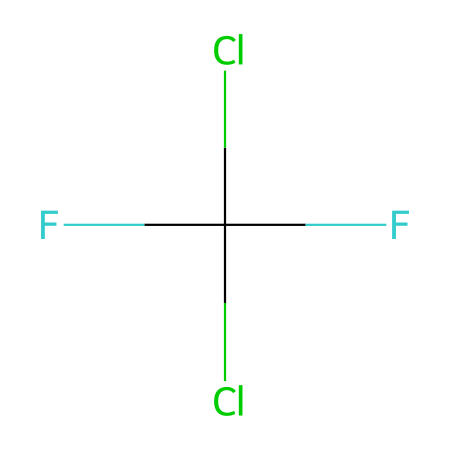What is the molecular formula of Freon-12? The SMILES representation shows the atoms present: carbon (C), fluorine (F), and chlorine (Cl). There's one carbon atom, two chlorine atoms, and four fluorine atoms. The molecular formula can be constructed as CCl2F2.
Answer: CCl2F2 How many halogen atoms are present in Freon-12? The SMILES structure indicates two chlorine (Cl) and four fluorine (F) atoms, making it a total of six halogen atoms present.
Answer: six What is the degree of saturation in Freon-12? Degree of saturation refers to the number of double or triple bonds present; as Freon-12 has single bonds only, it is fully saturated with hydrogen, yet has two halogen atoms making it less than fully saturated for hydrocarbons. The answer is zero for rings and multiple bonds.
Answer: zero Is Freon-12 an organic or inorganic compound? The presence of carbon (C) in its structure indicates it is an organic compound, specifically a fluorinated hydrocarbon.
Answer: organic What type of refrigerant is Freon-12 classified as? Freon-12 is classified as a chlorofluorocarbon (CFC), which is a group of compounds often used as refrigerants but now mostly phased out due to environmental concerns.
Answer: chlorofluorocarbon 